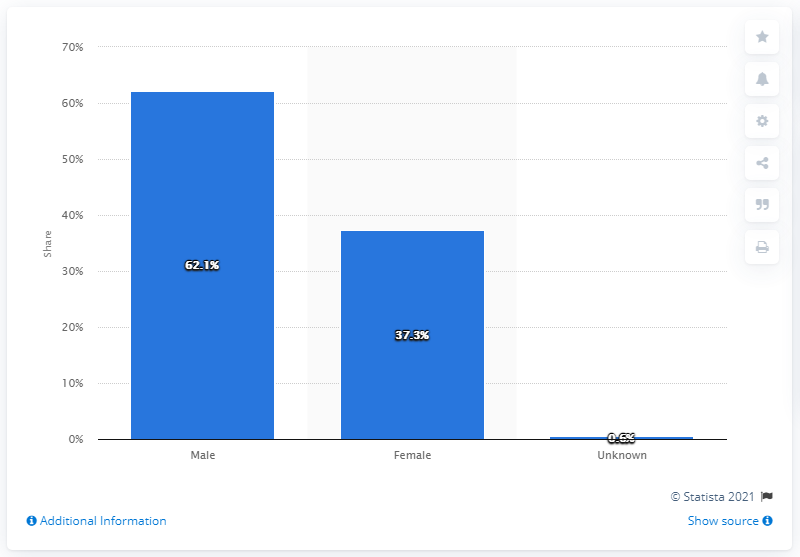Indicate a few pertinent items in this graphic. According to data from 2014, a total of 37.3% of employees in the media were female. 